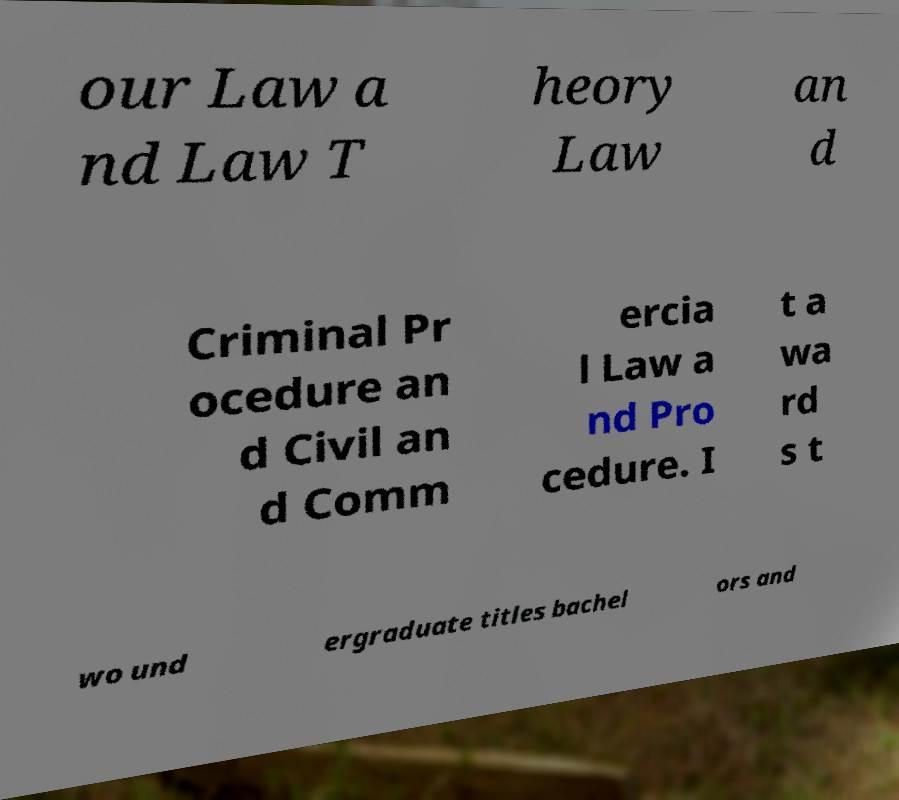Can you accurately transcribe the text from the provided image for me? our Law a nd Law T heory Law an d Criminal Pr ocedure an d Civil an d Comm ercia l Law a nd Pro cedure. I t a wa rd s t wo und ergraduate titles bachel ors and 